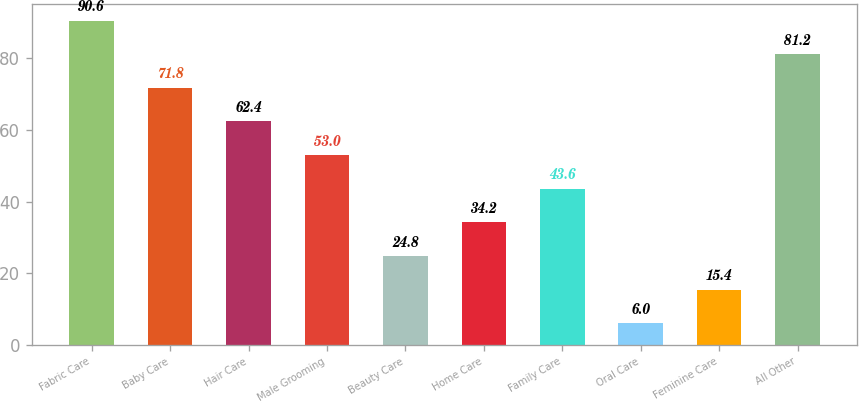Convert chart. <chart><loc_0><loc_0><loc_500><loc_500><bar_chart><fcel>Fabric Care<fcel>Baby Care<fcel>Hair Care<fcel>Male Grooming<fcel>Beauty Care<fcel>Home Care<fcel>Family Care<fcel>Oral Care<fcel>Feminine Care<fcel>All Other<nl><fcel>90.6<fcel>71.8<fcel>62.4<fcel>53<fcel>24.8<fcel>34.2<fcel>43.6<fcel>6<fcel>15.4<fcel>81.2<nl></chart> 